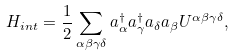<formula> <loc_0><loc_0><loc_500><loc_500>H _ { i n t } = \frac { 1 } { 2 } \sum _ { \alpha \beta \gamma \delta } a ^ { \dagger } _ { \alpha } a ^ { \dagger } _ { \gamma } a _ { \delta } a _ { \beta } U ^ { \alpha \beta \gamma \delta } ,</formula> 